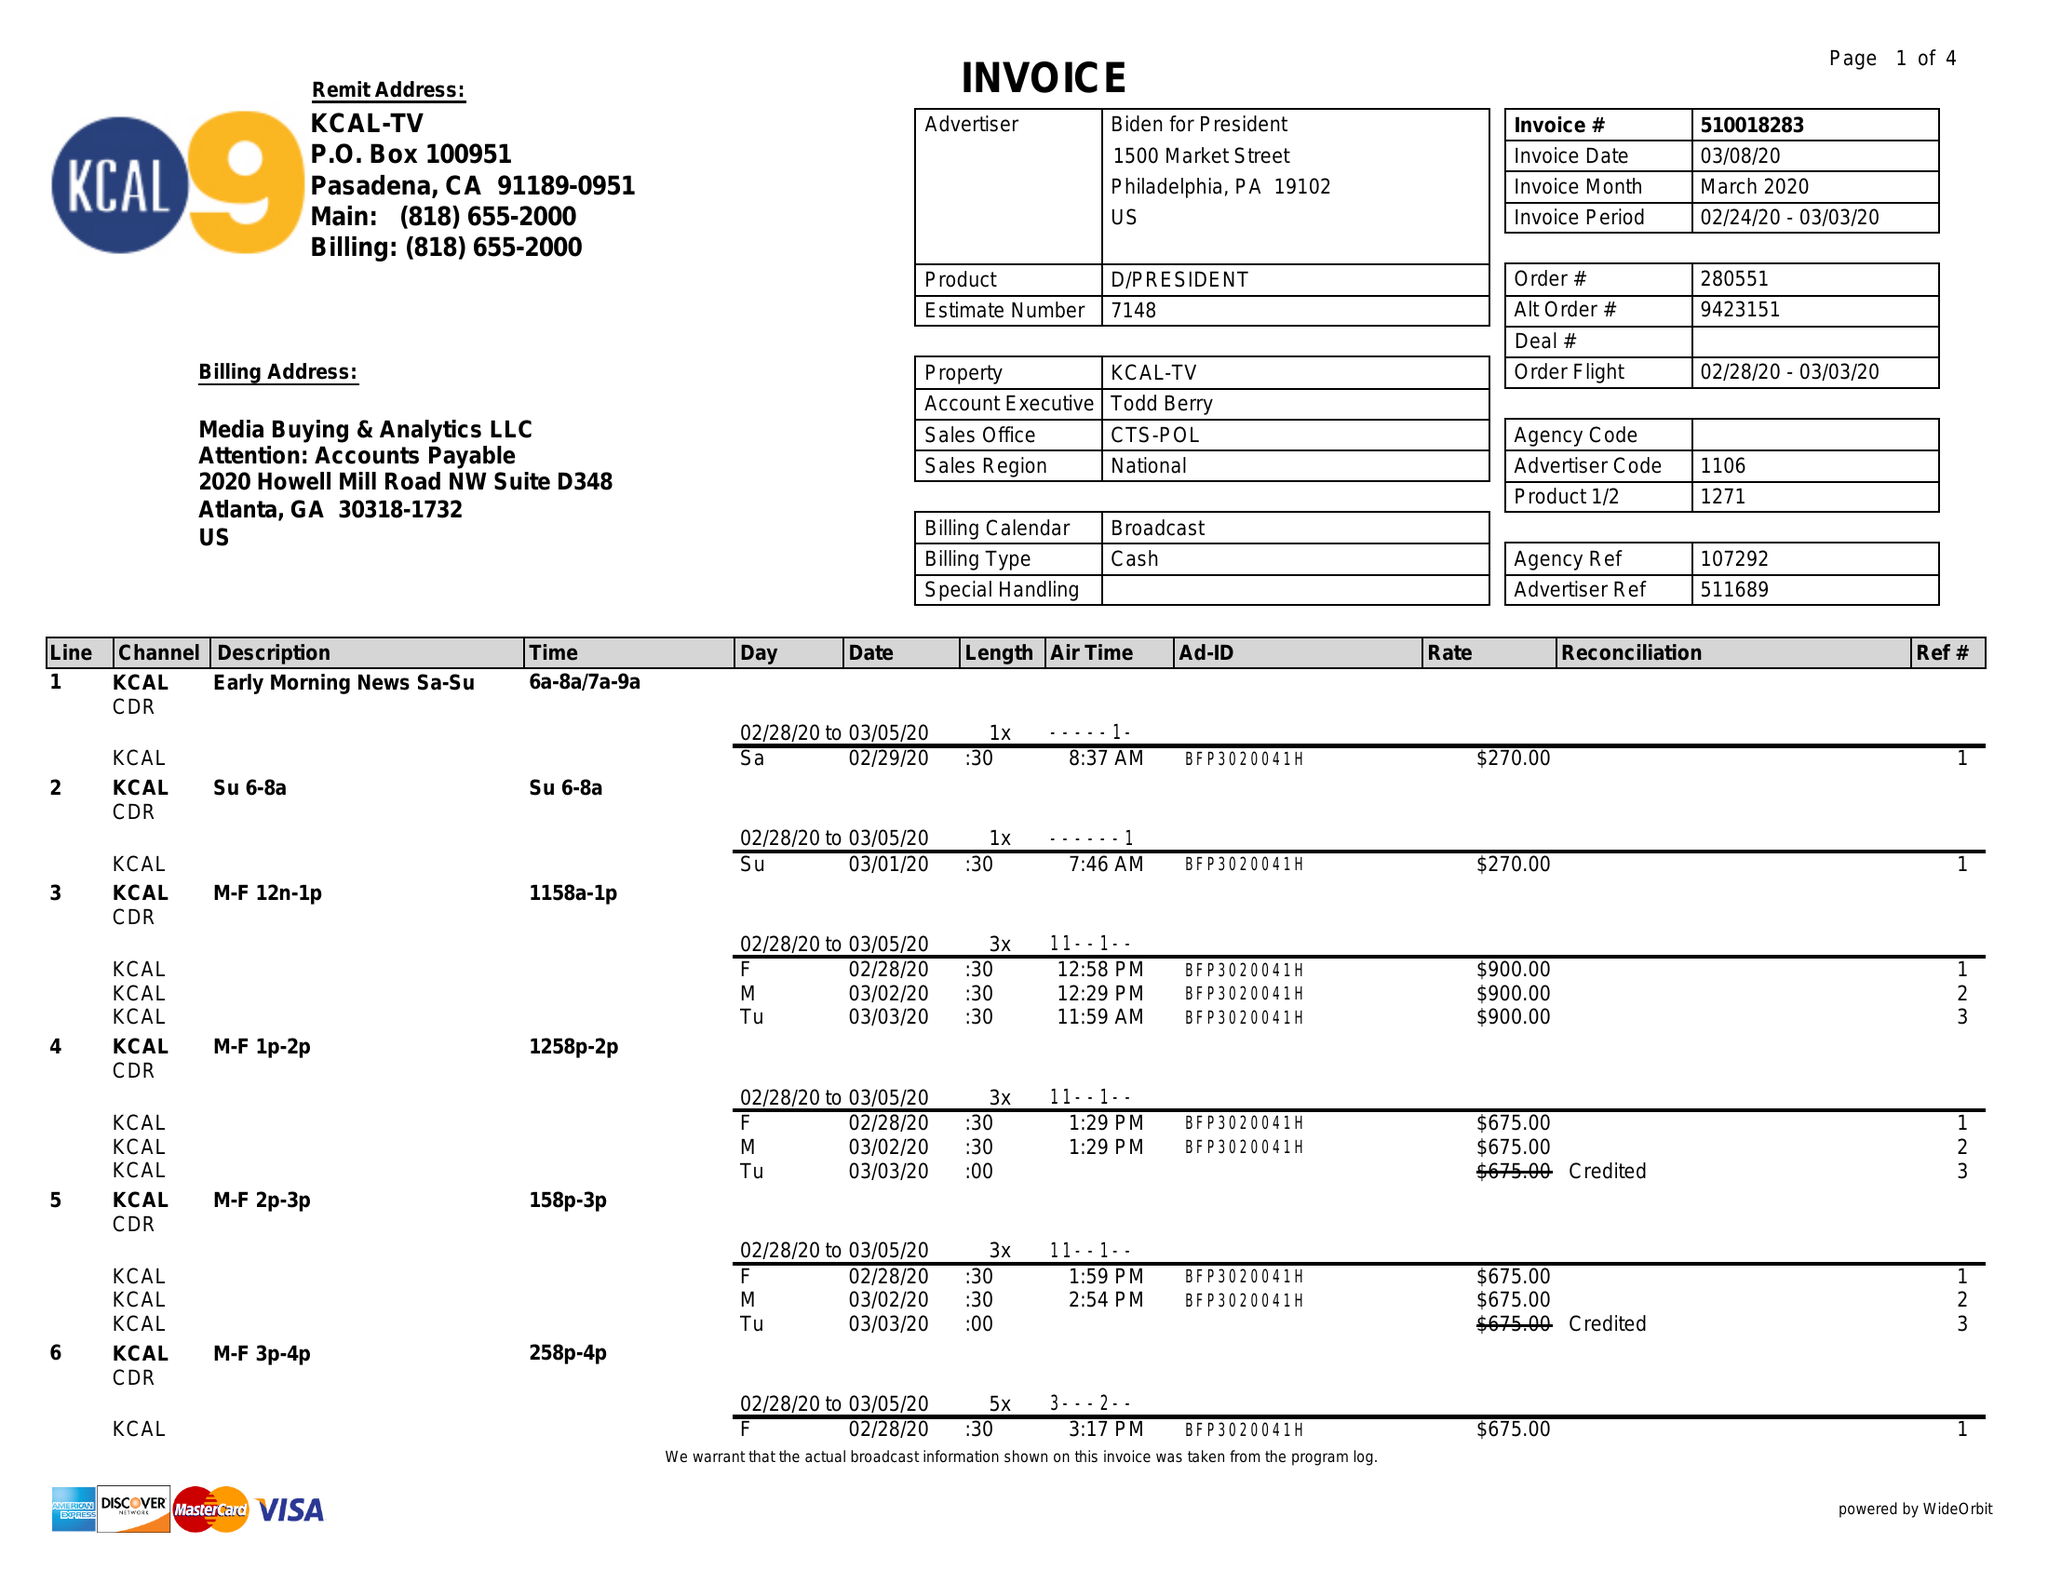What is the value for the gross_amount?
Answer the question using a single word or phrase. 43215.00 